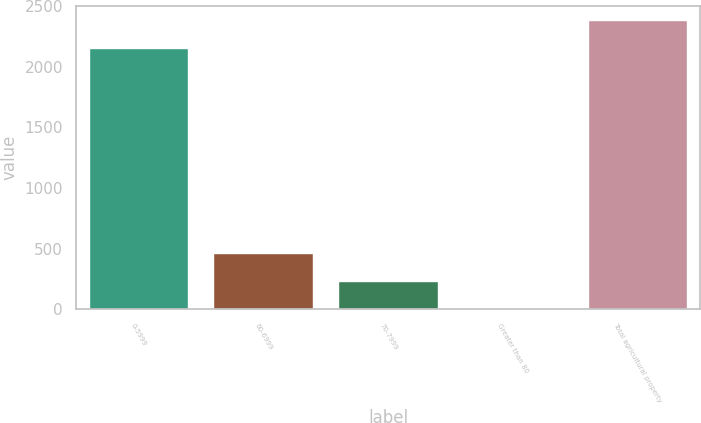Convert chart. <chart><loc_0><loc_0><loc_500><loc_500><bar_chart><fcel>0-5999<fcel>60-6999<fcel>70-7999<fcel>Greater than 80<fcel>Total agricultural property<nl><fcel>2152<fcel>463.24<fcel>233.27<fcel>3.3<fcel>2381.97<nl></chart> 